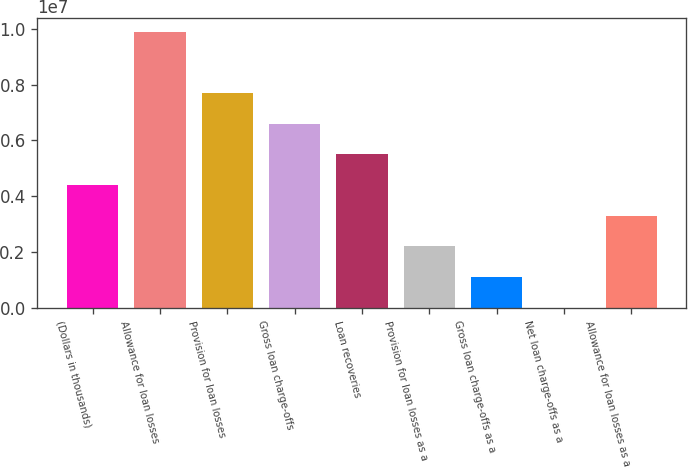Convert chart to OTSL. <chart><loc_0><loc_0><loc_500><loc_500><bar_chart><fcel>(Dollars in thousands)<fcel>Allowance for loan losses<fcel>Provision for loan losses<fcel>Gross loan charge-offs<fcel>Loan recoveries<fcel>Provision for loan losses as a<fcel>Gross loan charge-offs as a<fcel>Net loan charge-offs as a<fcel>Allowance for loan losses as a<nl><fcel>4.39811e+06<fcel>9.89574e+06<fcel>7.69669e+06<fcel>6.59716e+06<fcel>5.49763e+06<fcel>2.19905e+06<fcel>1.09953e+06<fcel>0.33<fcel>3.29858e+06<nl></chart> 